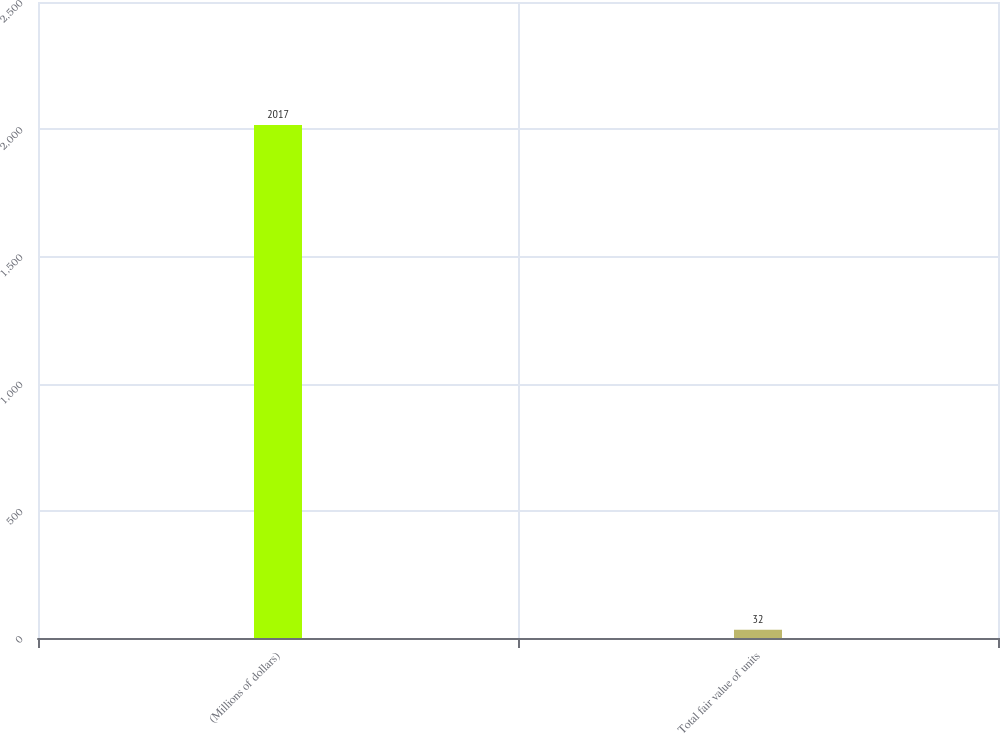Convert chart to OTSL. <chart><loc_0><loc_0><loc_500><loc_500><bar_chart><fcel>(Millions of dollars)<fcel>Total fair value of units<nl><fcel>2017<fcel>32<nl></chart> 